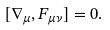<formula> <loc_0><loc_0><loc_500><loc_500>[ \nabla _ { \mu } , F _ { \mu \nu } ] = 0 .</formula> 